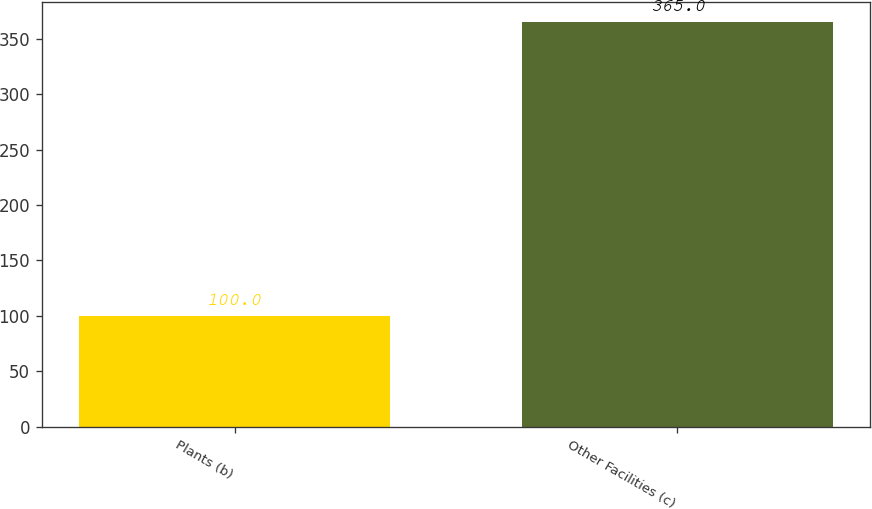Convert chart to OTSL. <chart><loc_0><loc_0><loc_500><loc_500><bar_chart><fcel>Plants (b)<fcel>Other Facilities (c)<nl><fcel>100<fcel>365<nl></chart> 